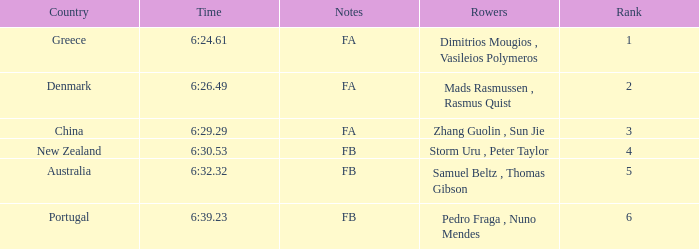61? Dimitrios Mougios , Vasileios Polymeros. 